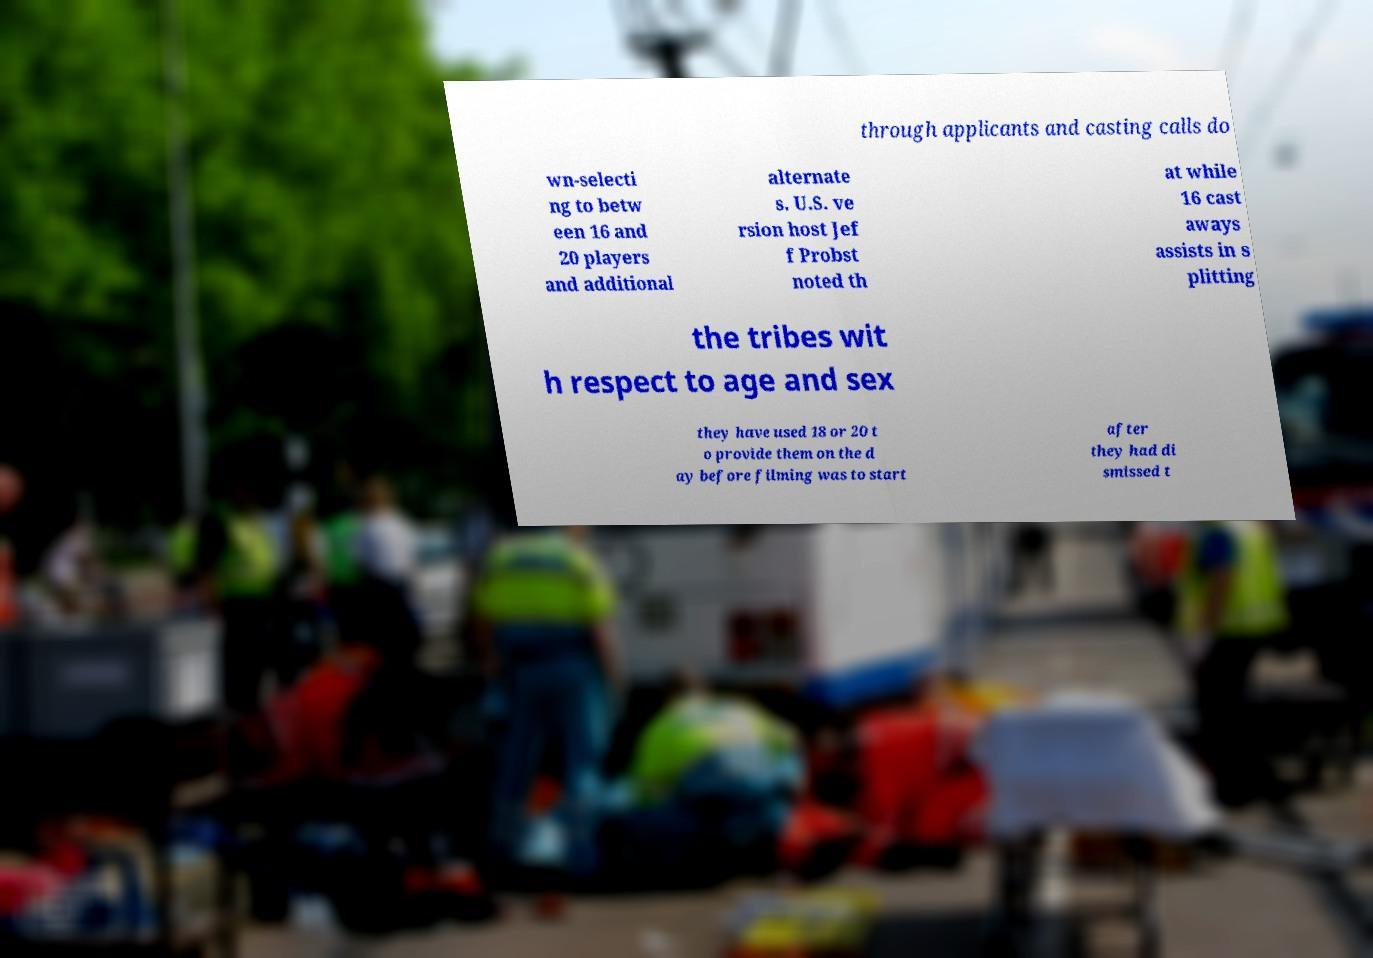Please identify and transcribe the text found in this image. through applicants and casting calls do wn-selecti ng to betw een 16 and 20 players and additional alternate s. U.S. ve rsion host Jef f Probst noted th at while 16 cast aways assists in s plitting the tribes wit h respect to age and sex they have used 18 or 20 t o provide them on the d ay before filming was to start after they had di smissed t 